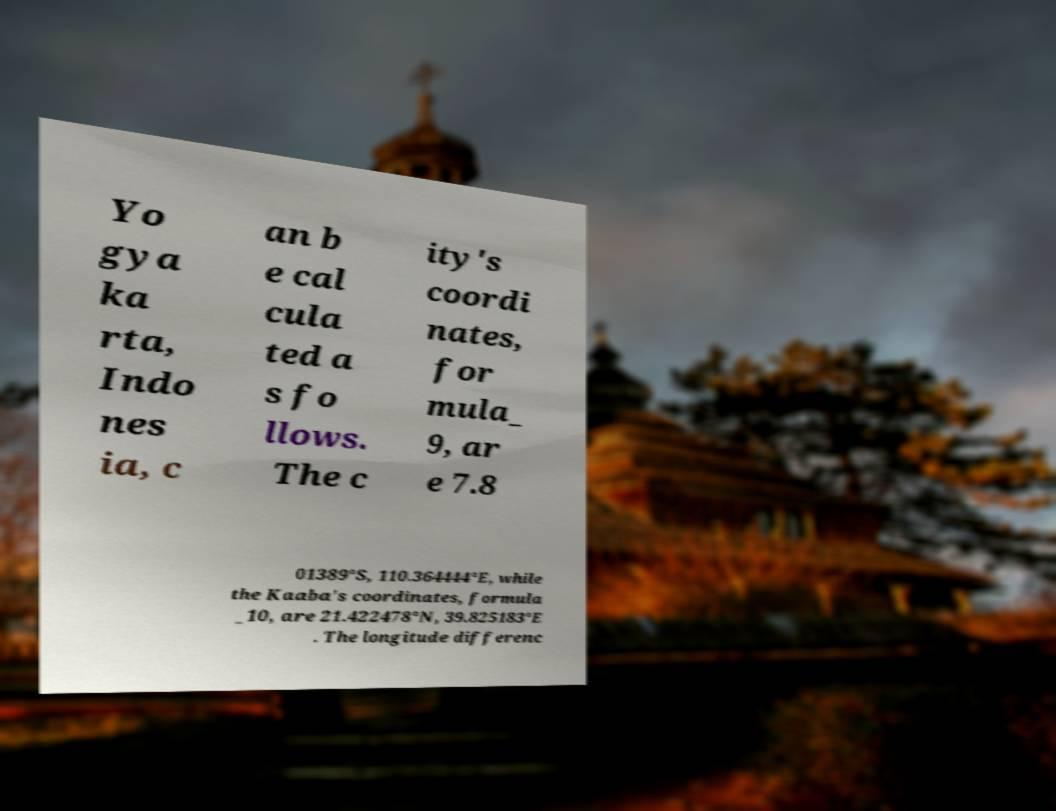What messages or text are displayed in this image? I need them in a readable, typed format. Yo gya ka rta, Indo nes ia, c an b e cal cula ted a s fo llows. The c ity's coordi nates, for mula_ 9, ar e 7.8 01389°S, 110.364444°E, while the Kaaba's coordinates, formula _10, are 21.422478°N, 39.825183°E . The longitude differenc 